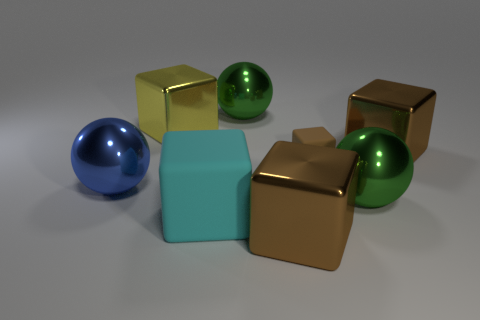How many cylinders are either brown rubber things or large yellow objects?
Your answer should be compact. 0. The small matte object is what color?
Your answer should be compact. Brown. Is the number of large green balls greater than the number of large yellow cubes?
Offer a very short reply. Yes. What number of objects are big metal objects that are in front of the yellow metal object or objects?
Give a very brief answer. 8. Does the yellow block have the same material as the small brown cube?
Offer a very short reply. No. There is a brown matte thing that is the same shape as the big cyan thing; what size is it?
Your answer should be very brief. Small. Does the brown metal object behind the big matte block have the same shape as the green object behind the large blue metal sphere?
Provide a short and direct response. No. Is the size of the blue metallic sphere the same as the green object that is behind the big blue object?
Provide a short and direct response. Yes. What number of other things are the same material as the small brown object?
Provide a succinct answer. 1. Is there anything else that has the same shape as the yellow shiny object?
Offer a very short reply. Yes. 